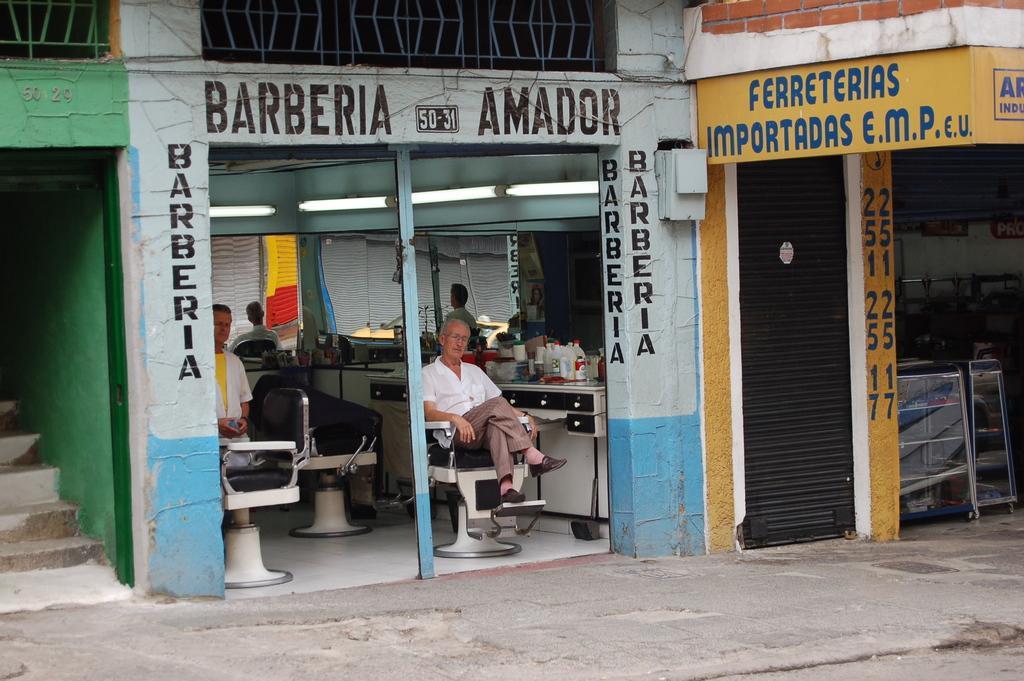Describe this image in one or two sentences. In this picture we can see man in front sitting on chair and at back of him we can see mirrors, bottles, some items on table and in background we can see steps, fence, shutter, glass, racks, wall. 